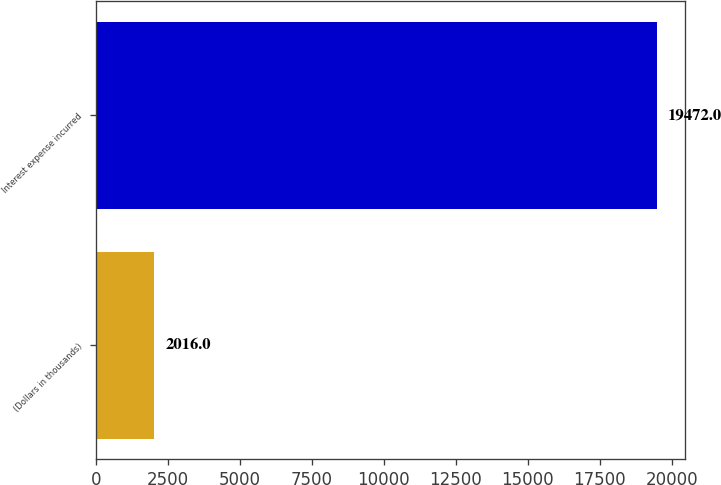Convert chart. <chart><loc_0><loc_0><loc_500><loc_500><bar_chart><fcel>(Dollars in thousands)<fcel>Interest expense incurred<nl><fcel>2016<fcel>19472<nl></chart> 